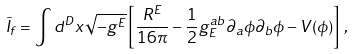Convert formula to latex. <formula><loc_0><loc_0><loc_500><loc_500>\tilde { I } _ { f } = \int d ^ { D } x \sqrt { - g ^ { E } } \left [ \frac { R ^ { E } } { 1 6 \pi } - \frac { 1 } { 2 } g _ { E } ^ { a b } \partial _ { a } \phi \partial _ { b } \phi - V ( \phi ) \right ] \, ,</formula> 